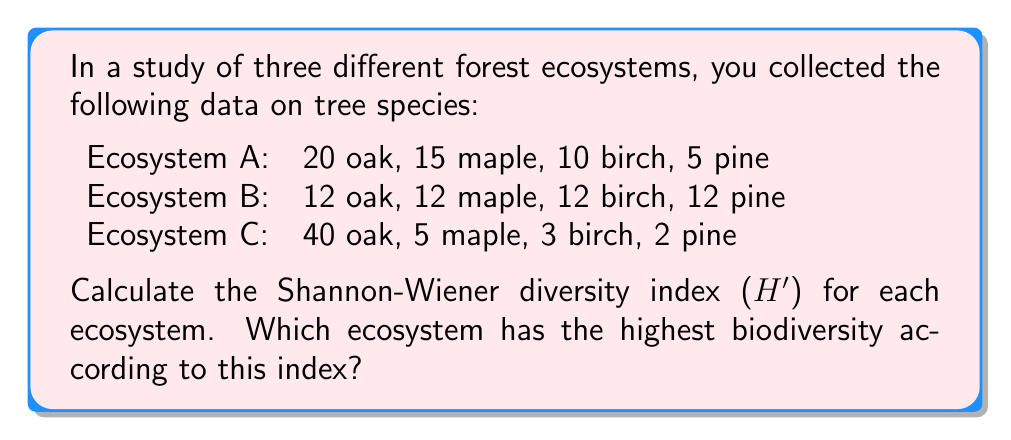Provide a solution to this math problem. To calculate the Shannon-Wiener diversity index (H'), we use the formula:

$$H' = -\sum_{i=1}^{R} p_i \ln(p_i)$$

Where:
$R$ = number of species
$p_i$ = proportion of individuals belonging to species $i$

Step 1: Calculate the total number of individuals and proportions for each ecosystem.

Ecosystem A: Total = 50
$p_{oak} = 20/50 = 0.4$, $p_{maple} = 15/50 = 0.3$, $p_{birch} = 10/50 = 0.2$, $p_{pine} = 5/50 = 0.1$

Ecosystem B: Total = 48
$p_{oak} = p_{maple} = p_{birch} = p_{pine} = 12/48 = 0.25$

Ecosystem C: Total = 50
$p_{oak} = 40/50 = 0.8$, $p_{maple} = 5/50 = 0.1$, $p_{birch} = 3/50 = 0.06$, $p_{pine} = 2/50 = 0.04$

Step 2: Calculate H' for each ecosystem.

Ecosystem A:
$$H'_A = -[0.4 \ln(0.4) + 0.3 \ln(0.3) + 0.2 \ln(0.2) + 0.1 \ln(0.1)] = 1.28$$

Ecosystem B:
$$H'_B = -[4 \times 0.25 \ln(0.25)] = 1.39$$

Ecosystem C:
$$H'_C = -[0.8 \ln(0.8) + 0.1 \ln(0.1) + 0.06 \ln(0.06) + 0.04 \ln(0.04)] = 0.71$$

Step 3: Compare the H' values.

Ecosystem B has the highest H' value (1.39), followed by Ecosystem A (1.28), and then Ecosystem C (0.71).
Answer: Ecosystem B has the highest biodiversity (H' = 1.39). 